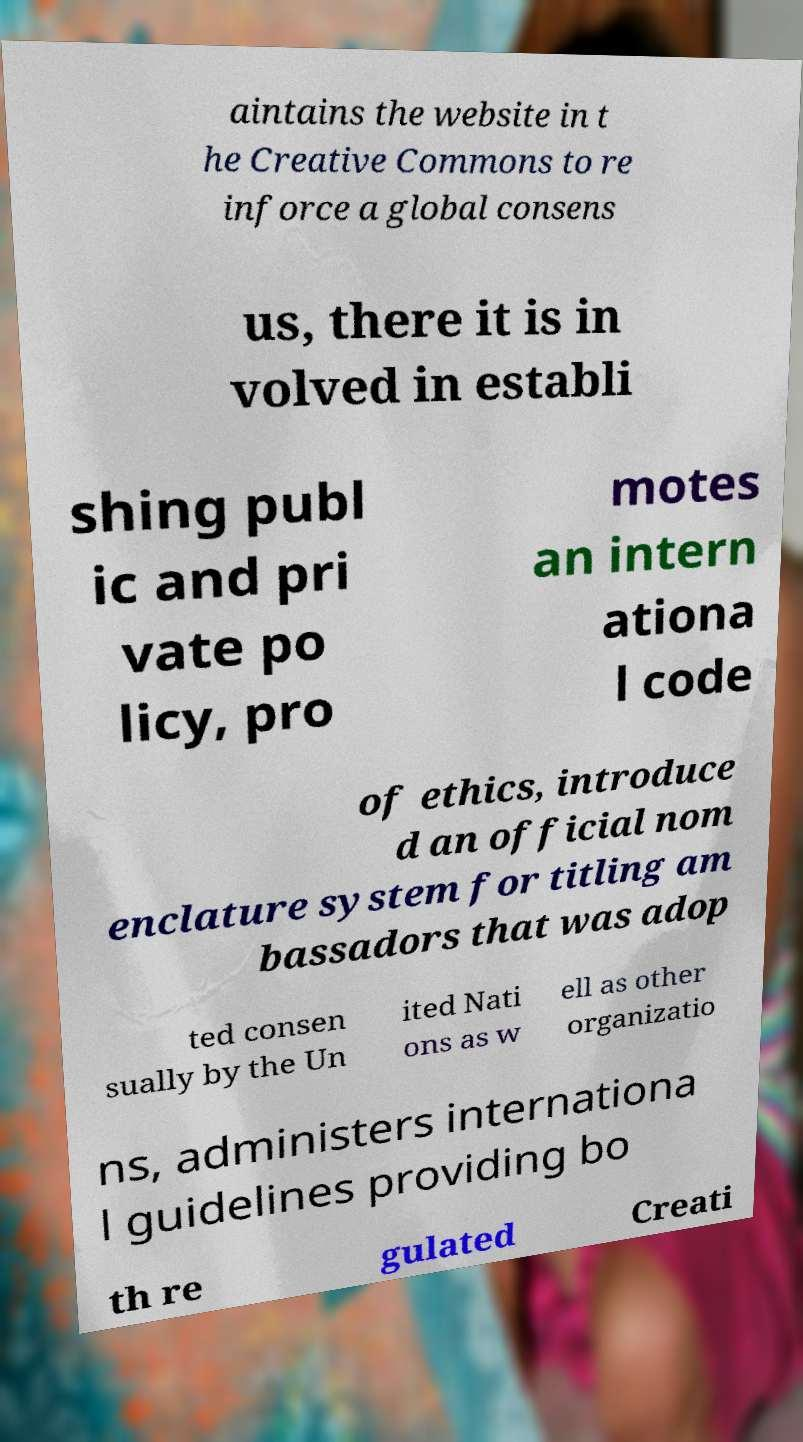Please read and relay the text visible in this image. What does it say? aintains the website in t he Creative Commons to re inforce a global consens us, there it is in volved in establi shing publ ic and pri vate po licy, pro motes an intern ationa l code of ethics, introduce d an official nom enclature system for titling am bassadors that was adop ted consen sually by the Un ited Nati ons as w ell as other organizatio ns, administers internationa l guidelines providing bo th re gulated Creati 